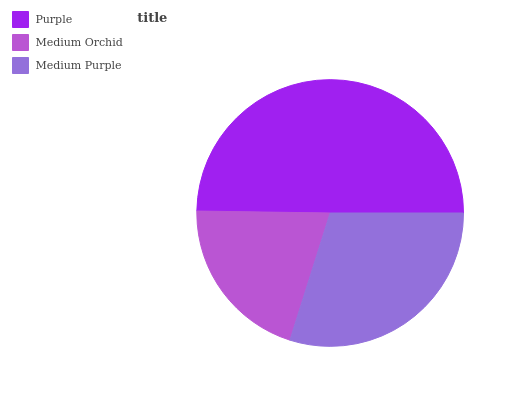Is Medium Orchid the minimum?
Answer yes or no. Yes. Is Purple the maximum?
Answer yes or no. Yes. Is Medium Purple the minimum?
Answer yes or no. No. Is Medium Purple the maximum?
Answer yes or no. No. Is Medium Purple greater than Medium Orchid?
Answer yes or no. Yes. Is Medium Orchid less than Medium Purple?
Answer yes or no. Yes. Is Medium Orchid greater than Medium Purple?
Answer yes or no. No. Is Medium Purple less than Medium Orchid?
Answer yes or no. No. Is Medium Purple the high median?
Answer yes or no. Yes. Is Medium Purple the low median?
Answer yes or no. Yes. Is Medium Orchid the high median?
Answer yes or no. No. Is Medium Orchid the low median?
Answer yes or no. No. 